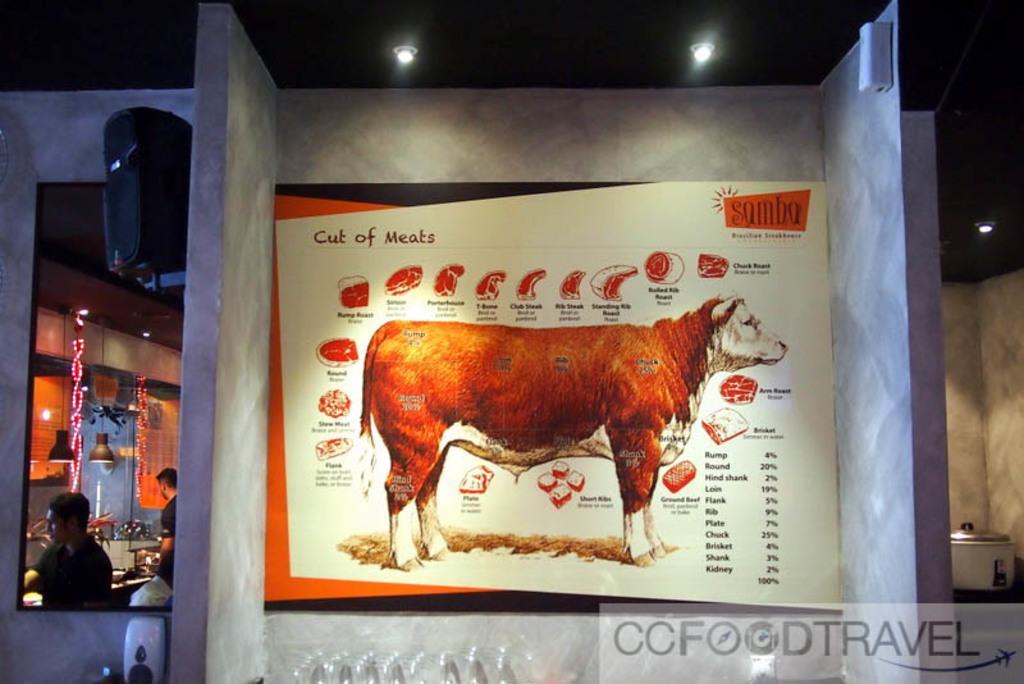Describe this image in one or two sentences. In this image, we can see a poster with some image and text. We can also see the wall. We can see a container on the right. There are a few people on the left. We can see some lights and objects. We can see some objects attached to the wall. We can also see the roof. 